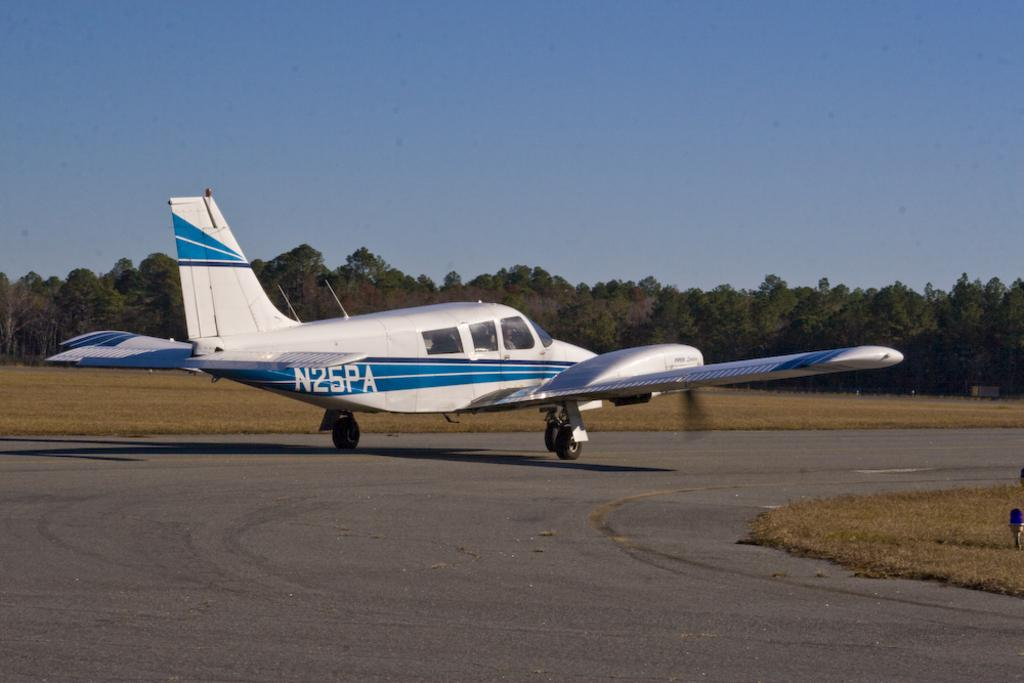<image>
Relay a brief, clear account of the picture shown. Silver and blue airplane that has a plate saying N25PA. 